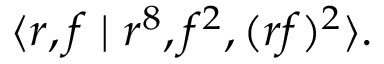<formula> <loc_0><loc_0><loc_500><loc_500>\langle r , f | r ^ { 8 } , f ^ { 2 } , ( r f ) ^ { 2 } \rangle .</formula> 